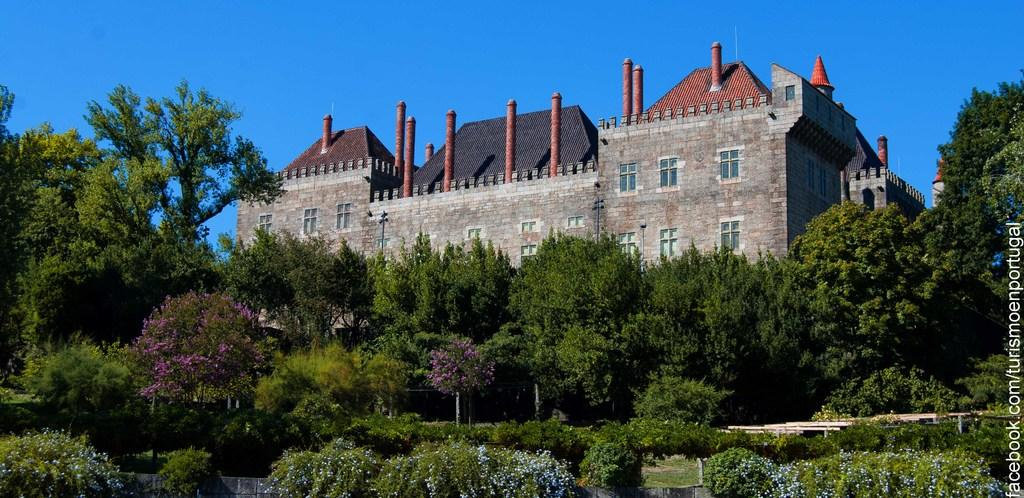What type of vegetation can be seen in the image? There are shrubs and trees in the image. What type of structure is present in the image? There is a stone building in the image. What color is the sky in the background of the image? The sky is blue in the background of the image. What type of toe can be seen in the image? There is no toe present in the image. 